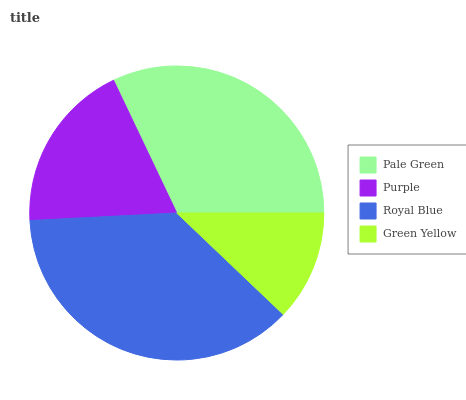Is Green Yellow the minimum?
Answer yes or no. Yes. Is Royal Blue the maximum?
Answer yes or no. Yes. Is Purple the minimum?
Answer yes or no. No. Is Purple the maximum?
Answer yes or no. No. Is Pale Green greater than Purple?
Answer yes or no. Yes. Is Purple less than Pale Green?
Answer yes or no. Yes. Is Purple greater than Pale Green?
Answer yes or no. No. Is Pale Green less than Purple?
Answer yes or no. No. Is Pale Green the high median?
Answer yes or no. Yes. Is Purple the low median?
Answer yes or no. Yes. Is Royal Blue the high median?
Answer yes or no. No. Is Pale Green the low median?
Answer yes or no. No. 